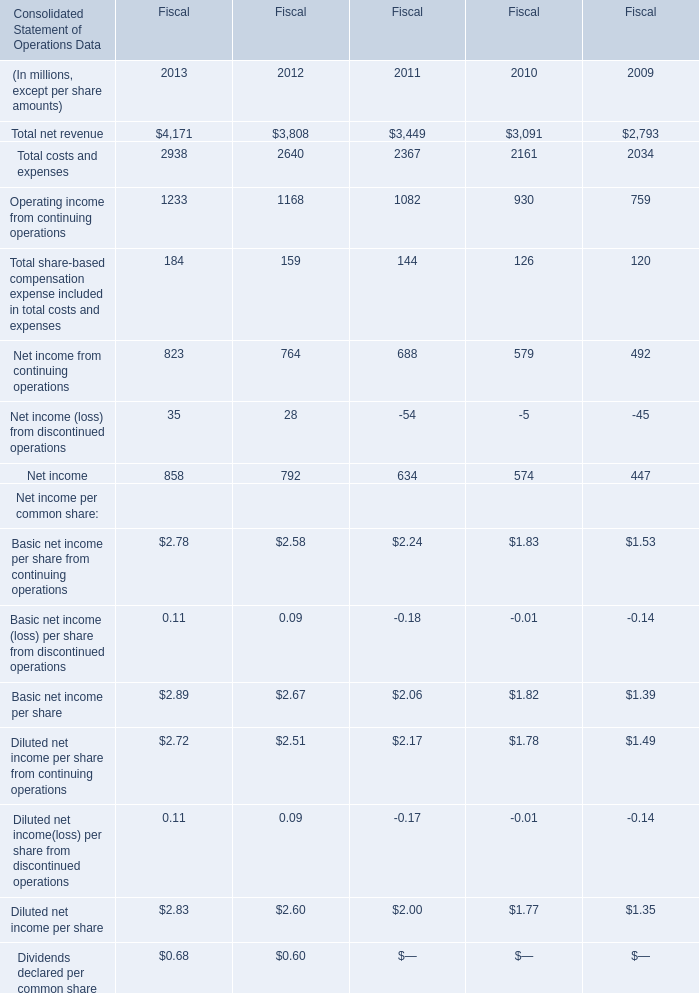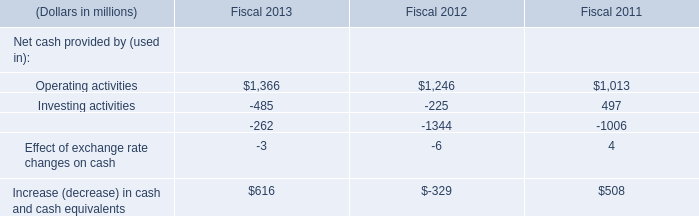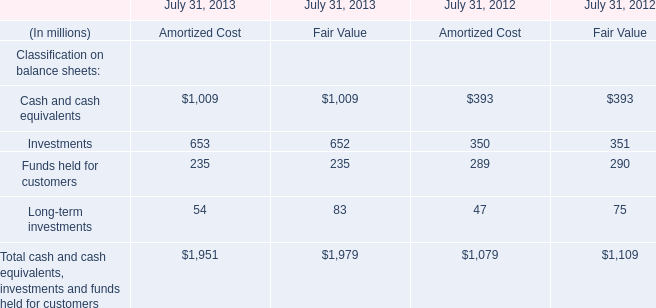what's the total amount of Operating income from continuing operations of Fiscal 2012, and Operating activities of Fiscal 2011 ? 
Computations: (1168.0 + 1013.0)
Answer: 2181.0. 